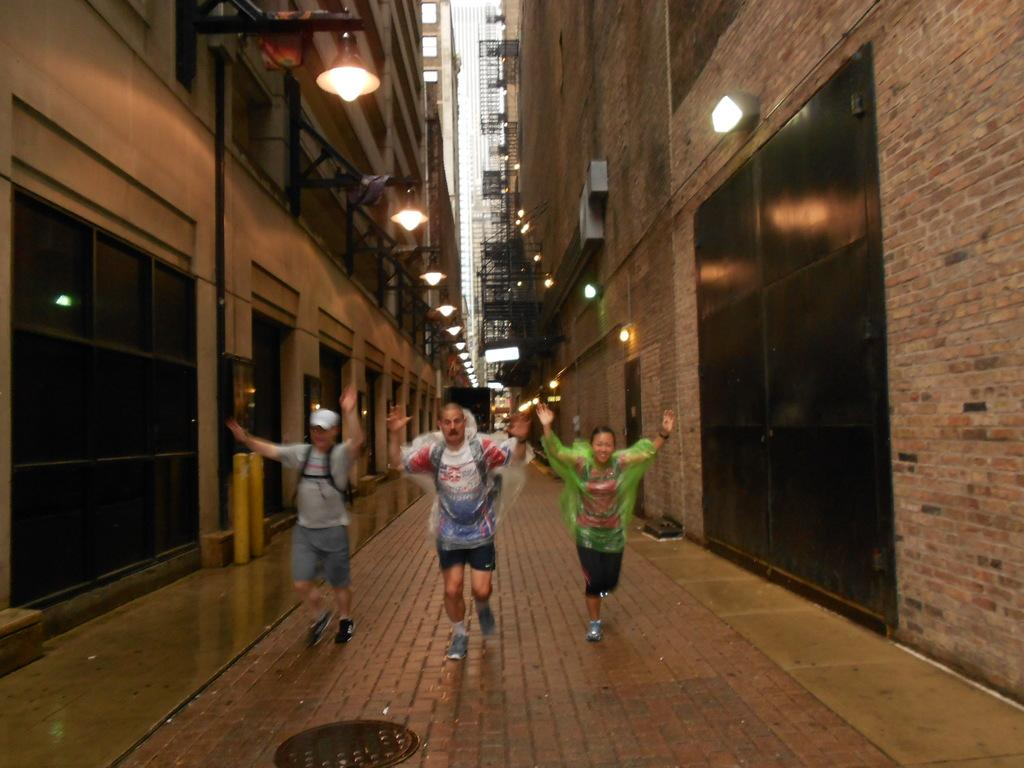How many persons can be seen in the image? There are persons in the image, but the exact number is not specified. What structures are located on the sides of the image? There is a building on the left side and a building on the right side of the image. What can be seen in the middle of the image? There are lights in the middle of the image. What type of train can be seen passing by the stage in the image? There is no train or stage present in the image. Is there a cable attached to the lights in the image? There is no mention of a cable attached to the lights in the image. 